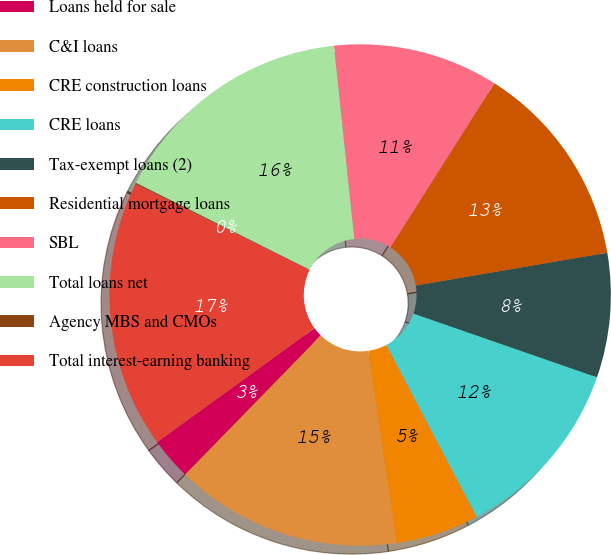<chart> <loc_0><loc_0><loc_500><loc_500><pie_chart><fcel>Loans held for sale<fcel>C&I loans<fcel>CRE construction loans<fcel>CRE loans<fcel>Tax-exempt loans (2)<fcel>Residential mortgage loans<fcel>SBL<fcel>Total loans net<fcel>Agency MBS and CMOs<fcel>Total interest-earning banking<nl><fcel>2.72%<fcel>14.63%<fcel>5.37%<fcel>11.98%<fcel>8.02%<fcel>13.31%<fcel>10.66%<fcel>15.95%<fcel>0.08%<fcel>17.28%<nl></chart> 